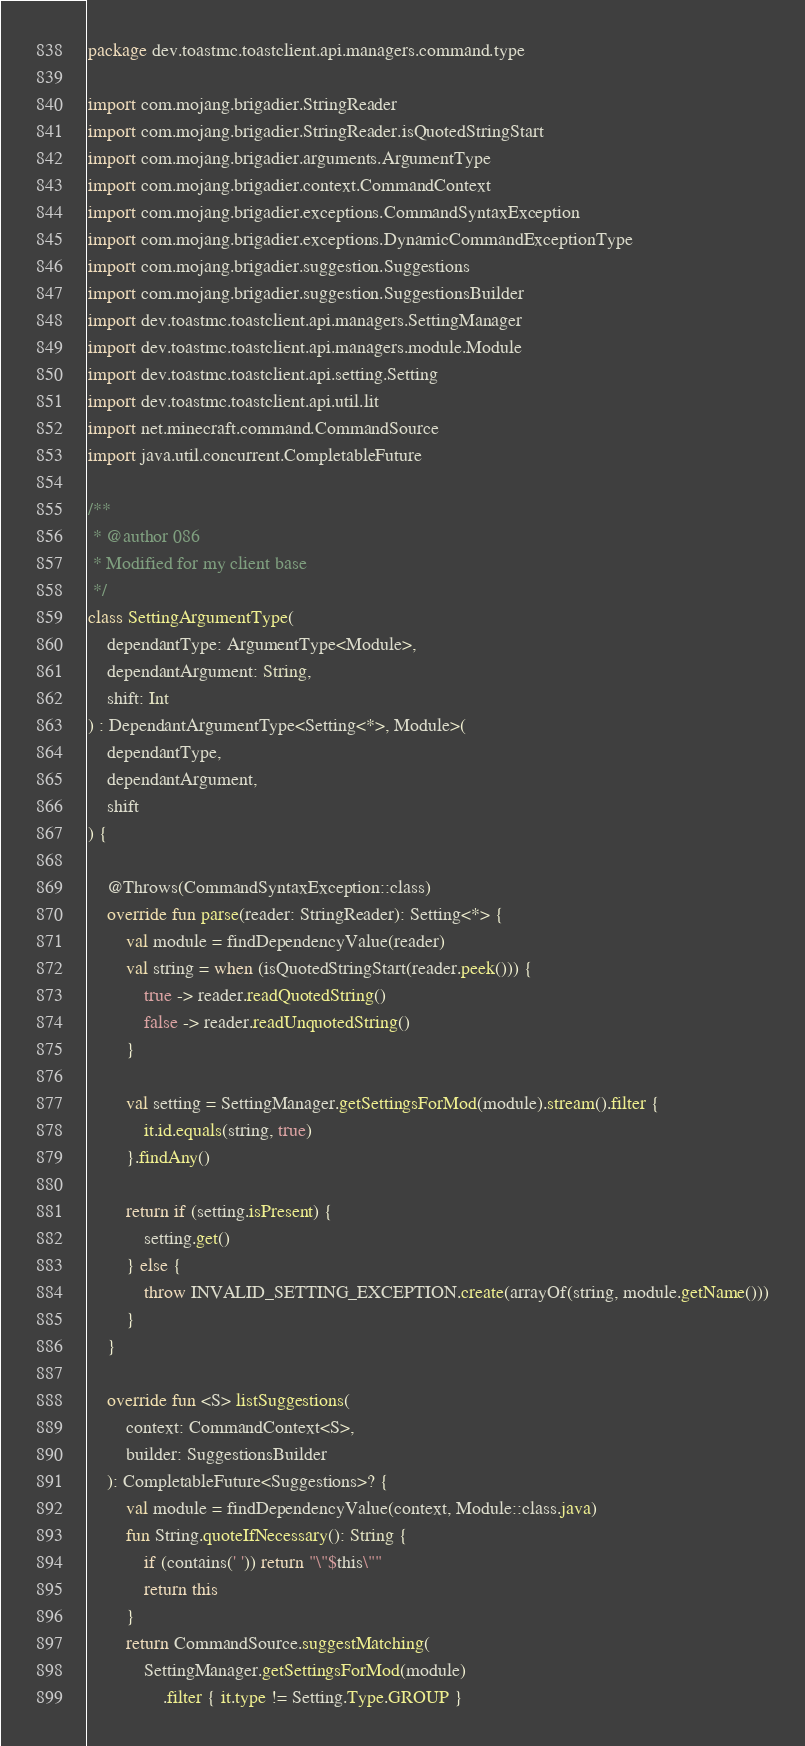<code> <loc_0><loc_0><loc_500><loc_500><_Kotlin_>package dev.toastmc.toastclient.api.managers.command.type

import com.mojang.brigadier.StringReader
import com.mojang.brigadier.StringReader.isQuotedStringStart
import com.mojang.brigadier.arguments.ArgumentType
import com.mojang.brigadier.context.CommandContext
import com.mojang.brigadier.exceptions.CommandSyntaxException
import com.mojang.brigadier.exceptions.DynamicCommandExceptionType
import com.mojang.brigadier.suggestion.Suggestions
import com.mojang.brigadier.suggestion.SuggestionsBuilder
import dev.toastmc.toastclient.api.managers.SettingManager
import dev.toastmc.toastclient.api.managers.module.Module
import dev.toastmc.toastclient.api.setting.Setting
import dev.toastmc.toastclient.api.util.lit
import net.minecraft.command.CommandSource
import java.util.concurrent.CompletableFuture

/**
 * @author 086
 * Modified for my client base
 */
class SettingArgumentType(
    dependantType: ArgumentType<Module>,
    dependantArgument: String,
    shift: Int
) : DependantArgumentType<Setting<*>, Module>(
    dependantType,
    dependantArgument,
    shift
) {

    @Throws(CommandSyntaxException::class)
    override fun parse(reader: StringReader): Setting<*> {
        val module = findDependencyValue(reader)
        val string = when (isQuotedStringStart(reader.peek())) {
            true -> reader.readQuotedString()
            false -> reader.readUnquotedString()
        }

        val setting = SettingManager.getSettingsForMod(module).stream().filter {
            it.id.equals(string, true)
        }.findAny()

        return if (setting.isPresent) {
            setting.get()
        } else {
            throw INVALID_SETTING_EXCEPTION.create(arrayOf(string, module.getName()))
        }
    }

    override fun <S> listSuggestions(
        context: CommandContext<S>,
        builder: SuggestionsBuilder
    ): CompletableFuture<Suggestions>? {
        val module = findDependencyValue(context, Module::class.java)
        fun String.quoteIfNecessary(): String {
            if (contains(' ')) return "\"$this\""
            return this
        }
        return CommandSource.suggestMatching(
            SettingManager.getSettingsForMod(module)
                .filter { it.type != Setting.Type.GROUP }</code> 